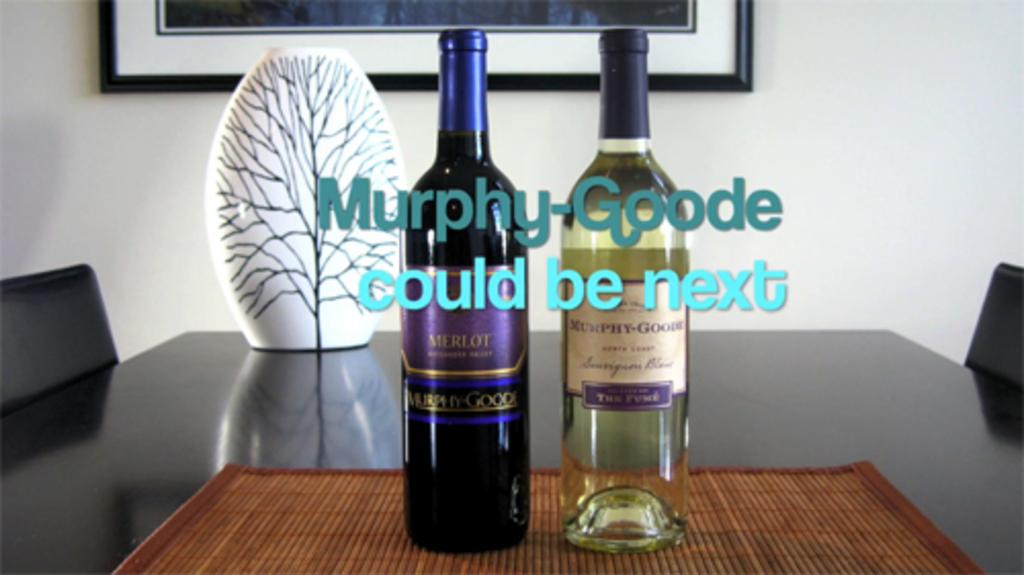What could be next?
Give a very brief answer. Murphy goode. What type of wine is in the bottle with the purple label?
Keep it short and to the point. Merlot. 